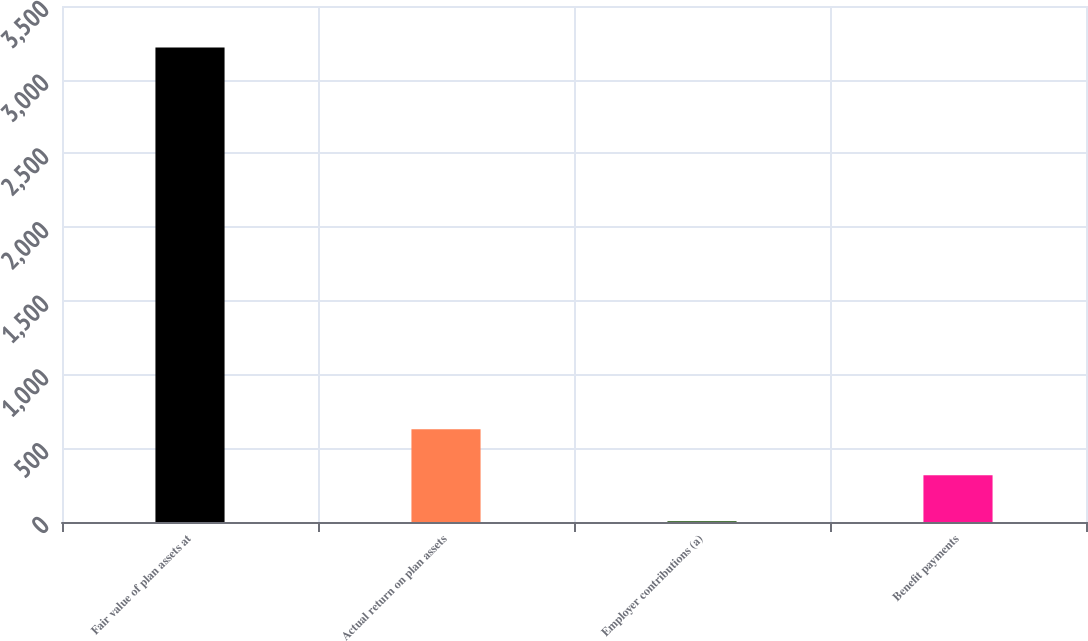Convert chart. <chart><loc_0><loc_0><loc_500><loc_500><bar_chart><fcel>Fair value of plan assets at<fcel>Actual return on plan assets<fcel>Employer contributions (a)<fcel>Benefit payments<nl><fcel>3218.4<fcel>628.8<fcel>6<fcel>317.4<nl></chart> 